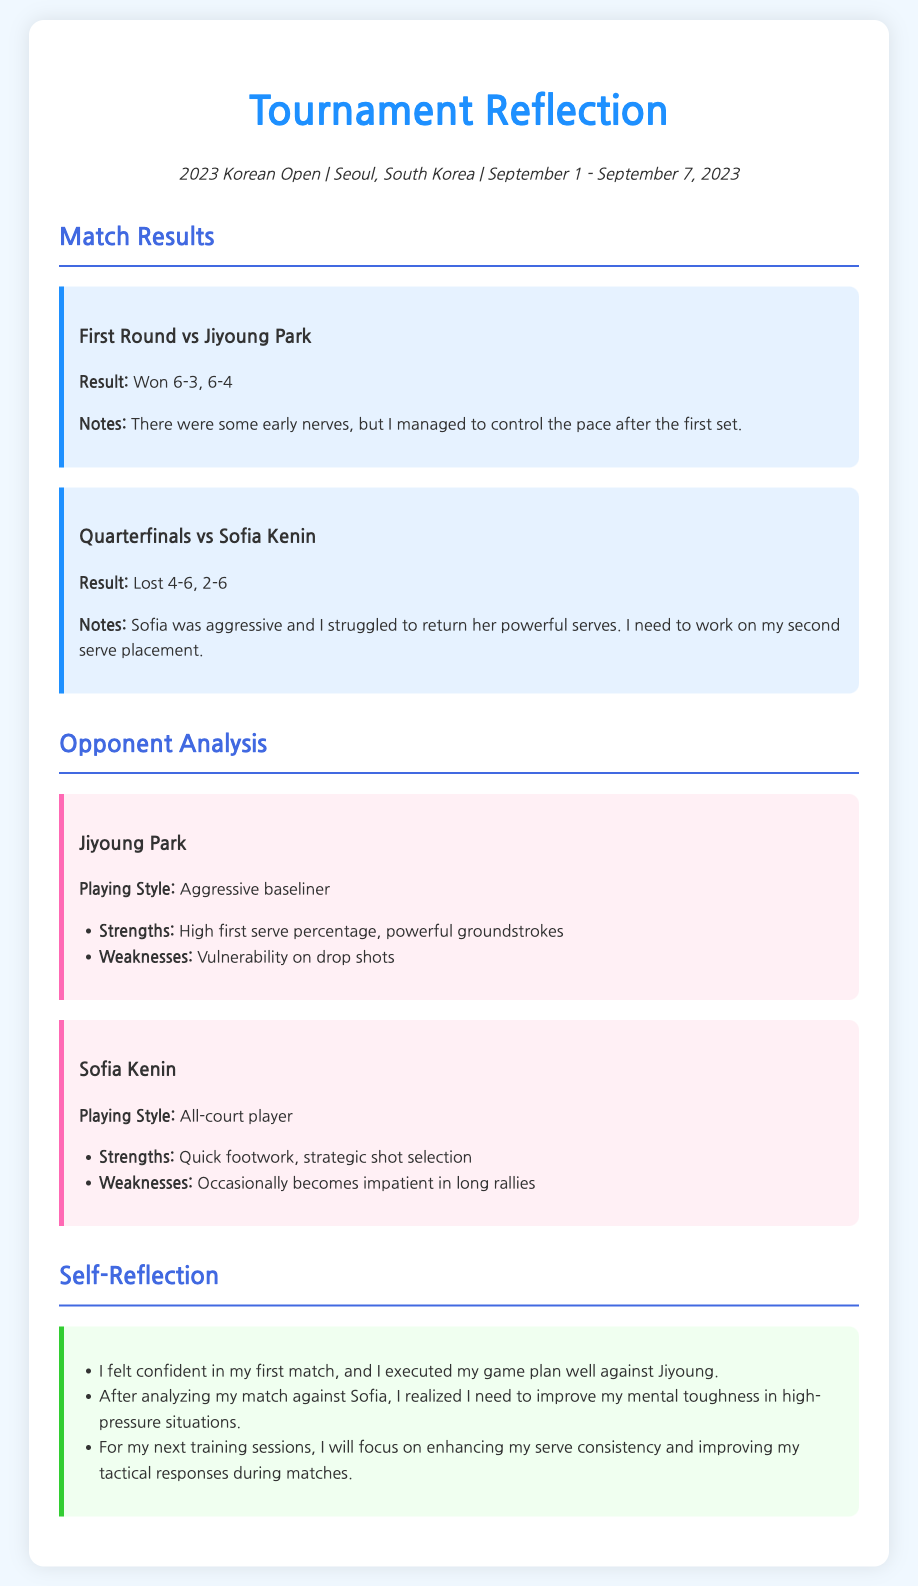What was the tournament's name? The document specifies the title of the tournament at the beginning, which is the 2023 Korean Open.
Answer: 2023 Korean Open Who did the player face in the quarterfinals? The document outlines match results, and it mentions that the player faced Sofia Kenin in the quarterfinals.
Answer: Sofia Kenin What was the result of the first round match? The match result section provides the outcome of the first round match against Jiyoung Park, stating the score as 6-3, 6-4.
Answer: Won 6-3, 6-4 What is one weakness of Sofia Kenin? The opponent analysis section lists weaknesses of Sofia Kenin, identifying that she occasionally becomes impatient in long rallies.
Answer: Occasionally becomes impatient in long rallies What area does the player intend to improve based on self-reflection? The self-reflection section reveals the player's focus for training sessions, specifically mentioning enhancing serve consistency.
Answer: Serve consistency 